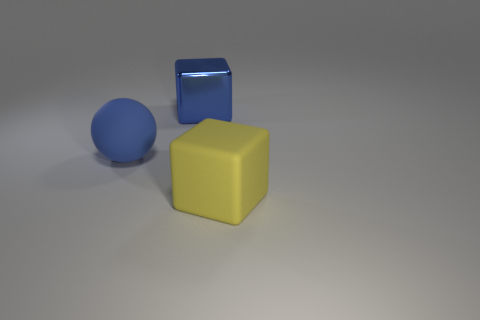There is a block that is the same color as the rubber sphere; what is its material?
Your response must be concise. Metal. What number of things are either blue things that are behind the blue ball or rubber objects?
Your answer should be compact. 3. There is a shiny thing that is the same shape as the large yellow matte thing; what is its color?
Your answer should be very brief. Blue. Is the shape of the big yellow thing the same as the big matte object on the left side of the yellow object?
Provide a short and direct response. No. What number of things are either big things to the right of the blue ball or big blue things behind the ball?
Your response must be concise. 2. Is the number of large blue metal objects to the left of the large blue shiny cube less than the number of large blue objects?
Your response must be concise. Yes. Are the large blue ball and the block that is behind the sphere made of the same material?
Your answer should be compact. No. What is the sphere made of?
Offer a terse response. Rubber. There is a block that is behind the rubber object that is on the left side of the object on the right side of the metallic thing; what is its material?
Your answer should be very brief. Metal. There is a rubber ball; does it have the same color as the big cube in front of the big metal thing?
Your response must be concise. No. 